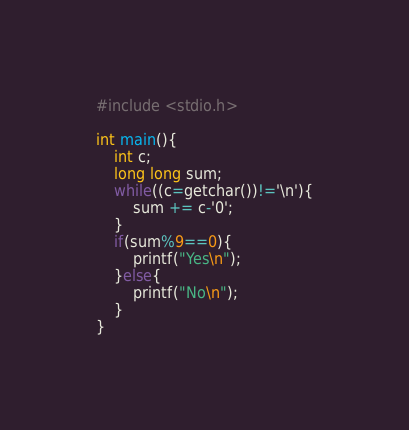<code> <loc_0><loc_0><loc_500><loc_500><_C_>#include <stdio.h>

int main(){
    int c;
    long long sum;
    while((c=getchar())!='\n'){
        sum += c-'0';
    }
    if(sum%9==0){
        printf("Yes\n");
    }else{
        printf("No\n");
    }
}</code> 